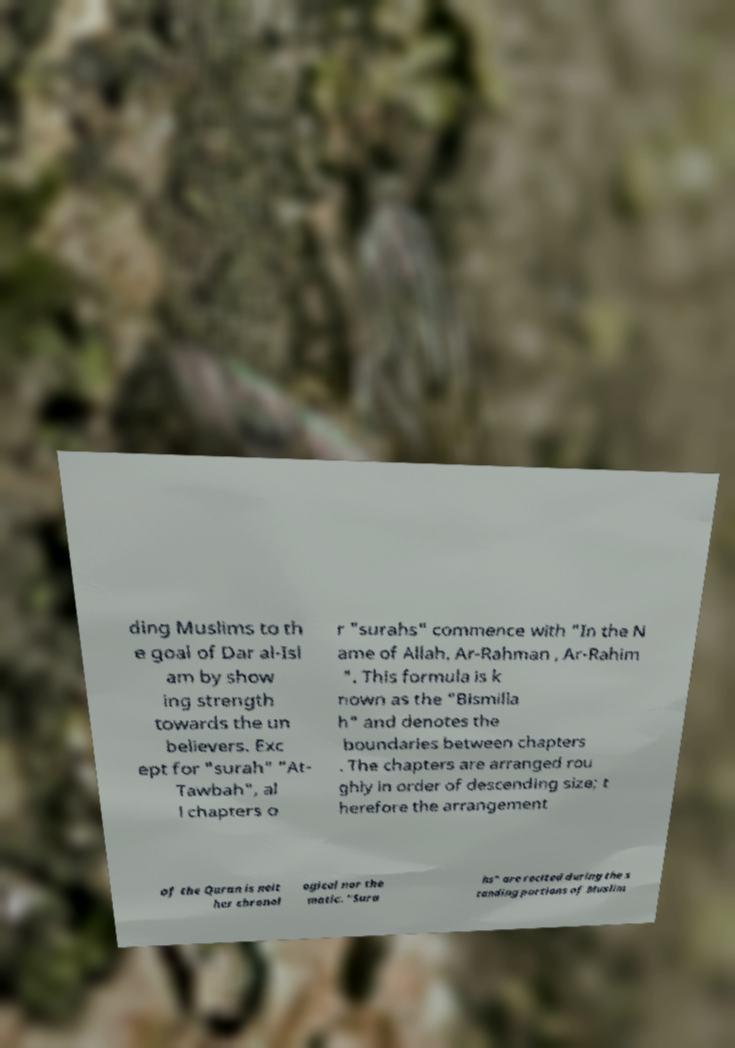There's text embedded in this image that I need extracted. Can you transcribe it verbatim? ding Muslims to th e goal of Dar al-Isl am by show ing strength towards the un believers. Exc ept for "surah" "At- Tawbah", al l chapters o r "surahs" commence with "In the N ame of Allah, Ar-Rahman , Ar-Rahim ". This formula is k nown as the "Bismilla h" and denotes the boundaries between chapters . The chapters are arranged rou ghly in order of descending size; t herefore the arrangement of the Quran is neit her chronol ogical nor the matic. "Sura hs" are recited during the s tanding portions of Muslim 